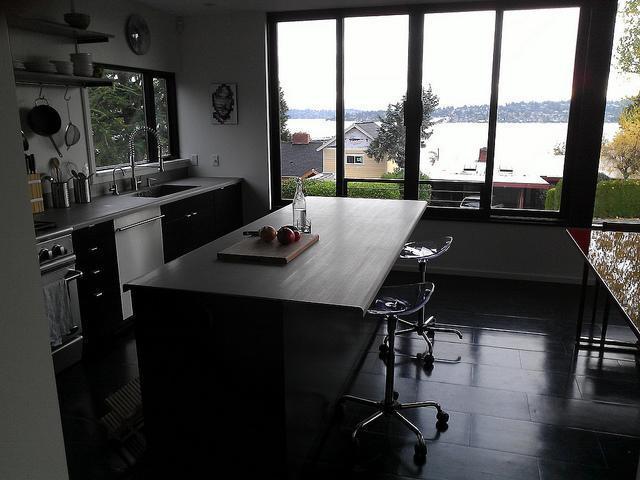How many dining tables are in the photo?
Give a very brief answer. 2. How many chairs are visible?
Give a very brief answer. 2. How many people have on red jackets?
Give a very brief answer. 0. 